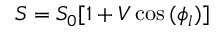<formula> <loc_0><loc_0><loc_500><loc_500>S = S _ { 0 } [ 1 + V \cos { ( \phi _ { l } ) } ]</formula> 